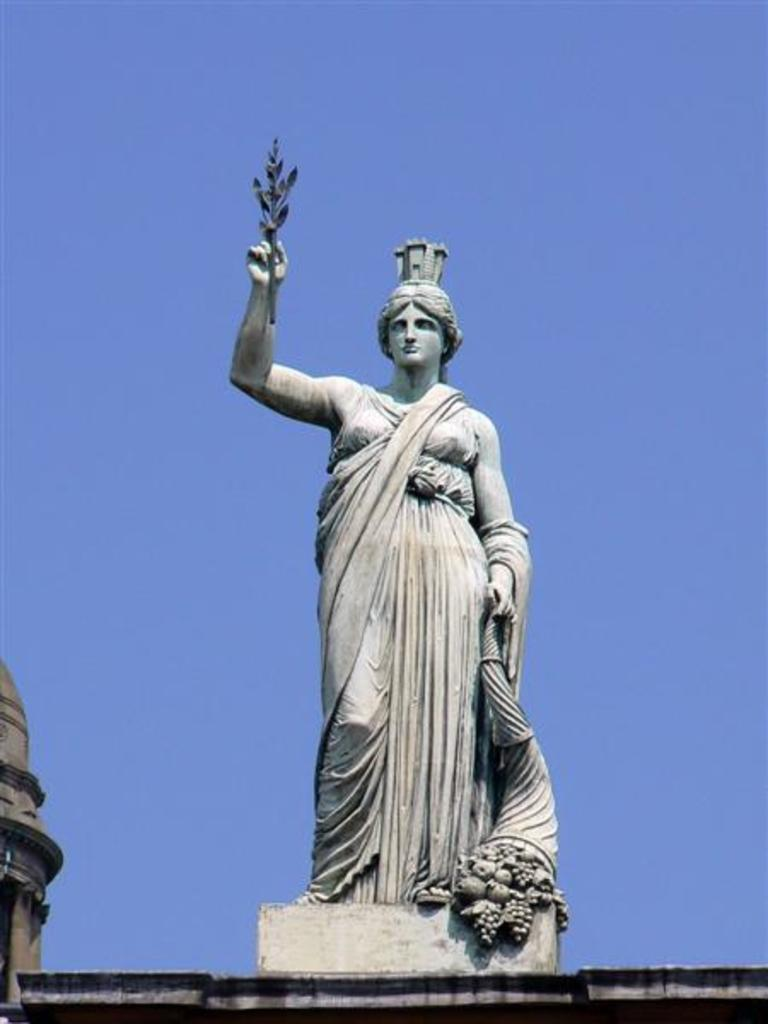What is the main subject of the image? There is a statue of a person in the image. Where is the statue located? The statue is on a building. What can be seen in the background of the image? The sky is visible in the background of the image. What type of pipe can be seen coming out of the cellar in the image? There is no cellar or pipe present in the image; it features a statue of a person on a building with the sky visible in the background. 